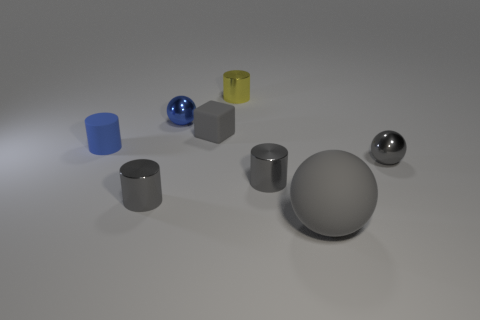Subtract all tiny blue shiny balls. How many balls are left? 2 Subtract all yellow blocks. How many gray cylinders are left? 2 Add 1 brown cylinders. How many objects exist? 9 Subtract all blue balls. How many balls are left? 2 Subtract 1 balls. How many balls are left? 2 Subtract all green cylinders. Subtract all brown cubes. How many cylinders are left? 4 Subtract all balls. How many objects are left? 5 Subtract all tiny blue objects. Subtract all large gray matte spheres. How many objects are left? 5 Add 5 tiny gray metal things. How many tiny gray metal things are left? 8 Add 5 gray shiny cylinders. How many gray shiny cylinders exist? 7 